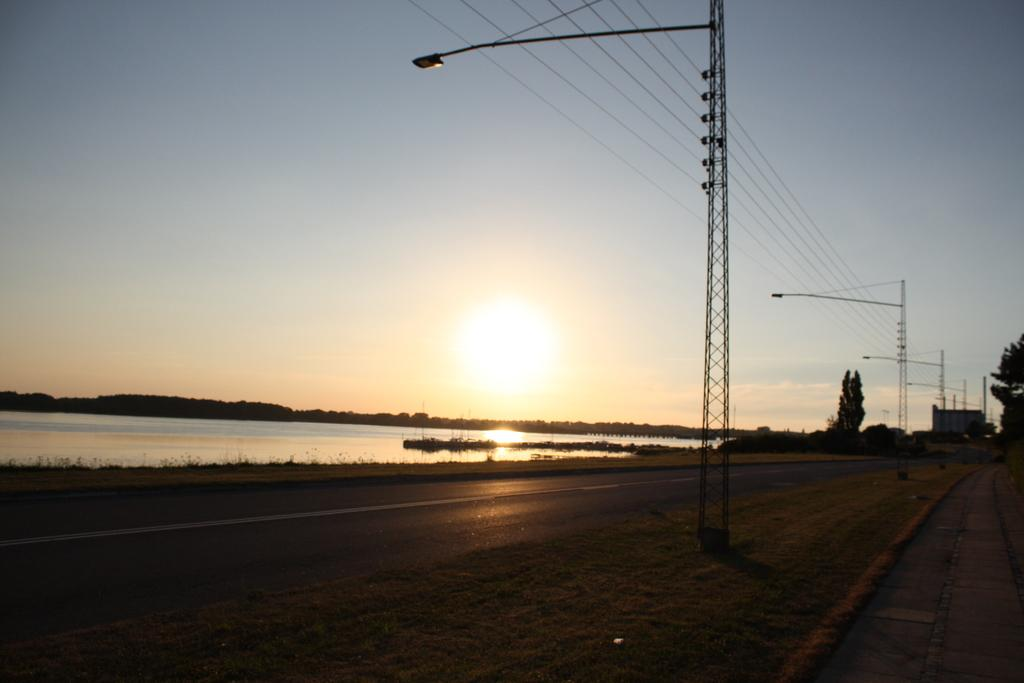What structures can be seen in the image? There are utility poles in the image. What else is present in the image besides the utility poles? Wires are present in the image. What type of vegetation is on the right side of the image? There are trees on the right side of the image. What can be seen at the bottom of the image? There is water visible at the bottom of the image. What type of pathway is in the image? There is a road in the image. What language is spoken by the writer in the image? There is no writer or spoken language present in the image. 